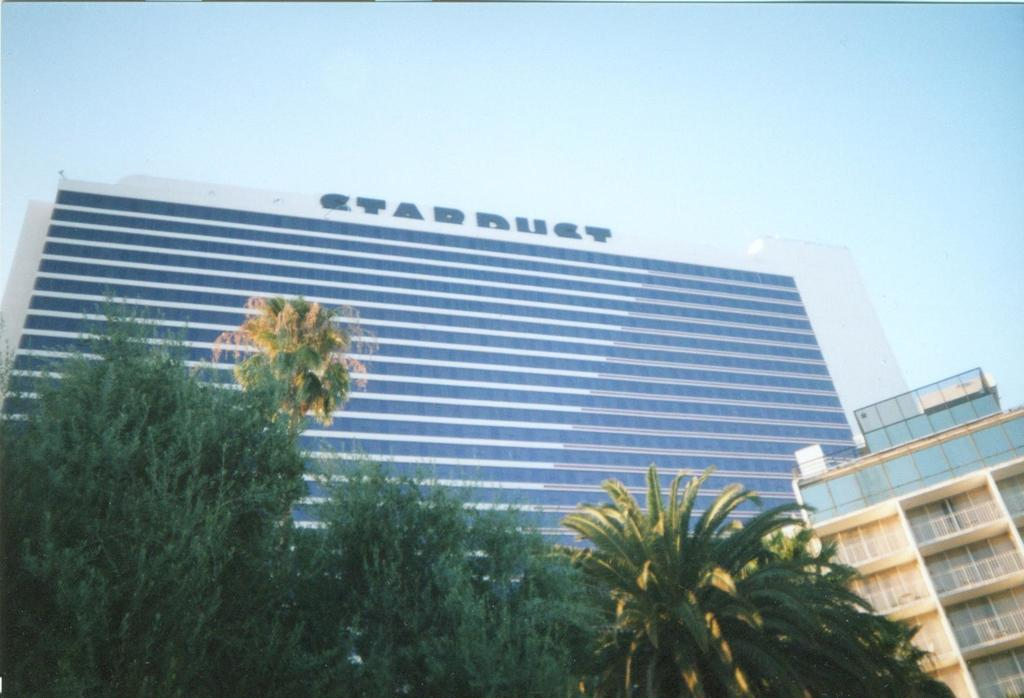What type of structures can be seen in the image? There are buildings in the image. What other natural elements are present in the image? There are trees in the image. How would you describe the sky in the image? The sky is blue and cloudy in the image. How many letters are being held by the dolls in the image? There are no dolls present in the image, so there are no letters being held by dolls. What type of bite can be seen on the tree in the image? There is no bite visible on the tree in the image. 